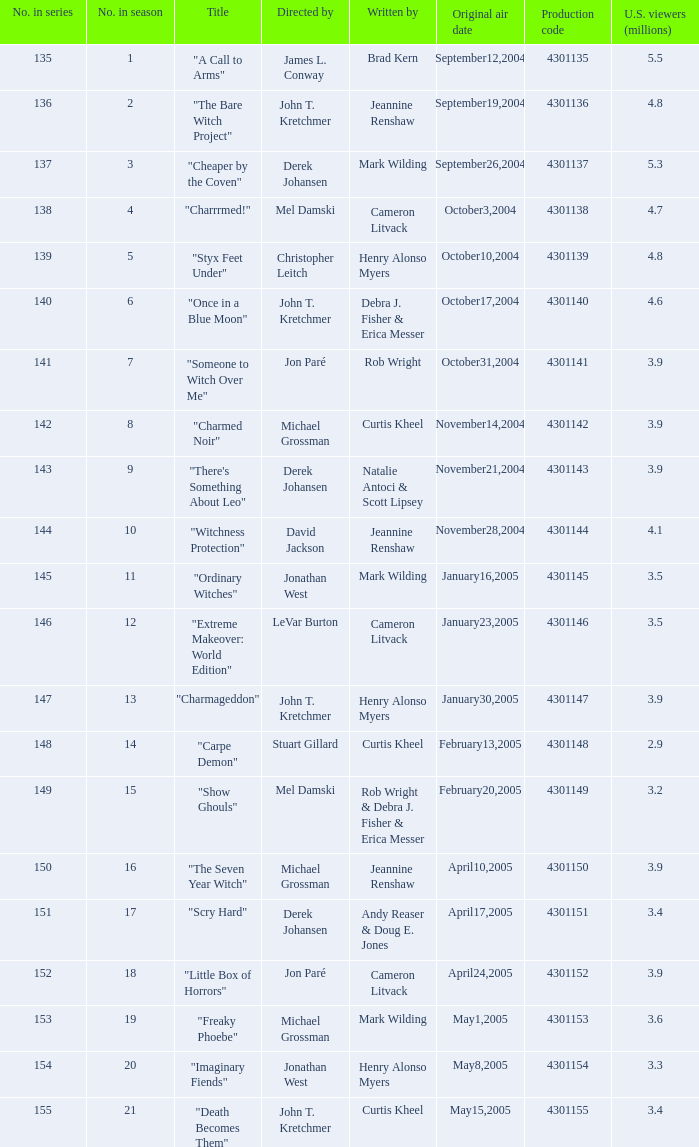What was the designation of the episode that garnered "Imaginary Fiends". Can you give me this table as a dict? {'header': ['No. in series', 'No. in season', 'Title', 'Directed by', 'Written by', 'Original air date', 'Production code', 'U.S. viewers (millions)'], 'rows': [['135', '1', '"A Call to Arms"', 'James L. Conway', 'Brad Kern', 'September12,2004', '4301135', '5.5'], ['136', '2', '"The Bare Witch Project"', 'John T. Kretchmer', 'Jeannine Renshaw', 'September19,2004', '4301136', '4.8'], ['137', '3', '"Cheaper by the Coven"', 'Derek Johansen', 'Mark Wilding', 'September26,2004', '4301137', '5.3'], ['138', '4', '"Charrrmed!"', 'Mel Damski', 'Cameron Litvack', 'October3,2004', '4301138', '4.7'], ['139', '5', '"Styx Feet Under"', 'Christopher Leitch', 'Henry Alonso Myers', 'October10,2004', '4301139', '4.8'], ['140', '6', '"Once in a Blue Moon"', 'John T. Kretchmer', 'Debra J. Fisher & Erica Messer', 'October17,2004', '4301140', '4.6'], ['141', '7', '"Someone to Witch Over Me"', 'Jon Paré', 'Rob Wright', 'October31,2004', '4301141', '3.9'], ['142', '8', '"Charmed Noir"', 'Michael Grossman', 'Curtis Kheel', 'November14,2004', '4301142', '3.9'], ['143', '9', '"There\'s Something About Leo"', 'Derek Johansen', 'Natalie Antoci & Scott Lipsey', 'November21,2004', '4301143', '3.9'], ['144', '10', '"Witchness Protection"', 'David Jackson', 'Jeannine Renshaw', 'November28,2004', '4301144', '4.1'], ['145', '11', '"Ordinary Witches"', 'Jonathan West', 'Mark Wilding', 'January16,2005', '4301145', '3.5'], ['146', '12', '"Extreme Makeover: World Edition"', 'LeVar Burton', 'Cameron Litvack', 'January23,2005', '4301146', '3.5'], ['147', '13', '"Charmageddon"', 'John T. Kretchmer', 'Henry Alonso Myers', 'January30,2005', '4301147', '3.9'], ['148', '14', '"Carpe Demon"', 'Stuart Gillard', 'Curtis Kheel', 'February13,2005', '4301148', '2.9'], ['149', '15', '"Show Ghouls"', 'Mel Damski', 'Rob Wright & Debra J. Fisher & Erica Messer', 'February20,2005', '4301149', '3.2'], ['150', '16', '"The Seven Year Witch"', 'Michael Grossman', 'Jeannine Renshaw', 'April10,2005', '4301150', '3.9'], ['151', '17', '"Scry Hard"', 'Derek Johansen', 'Andy Reaser & Doug E. Jones', 'April17,2005', '4301151', '3.4'], ['152', '18', '"Little Box of Horrors"', 'Jon Paré', 'Cameron Litvack', 'April24,2005', '4301152', '3.9'], ['153', '19', '"Freaky Phoebe"', 'Michael Grossman', 'Mark Wilding', 'May1,2005', '4301153', '3.6'], ['154', '20', '"Imaginary Fiends"', 'Jonathan West', 'Henry Alonso Myers', 'May8,2005', '4301154', '3.3'], ['155', '21', '"Death Becomes Them"', 'John T. Kretchmer', 'Curtis Kheel', 'May15,2005', '4301155', '3.4']]} 